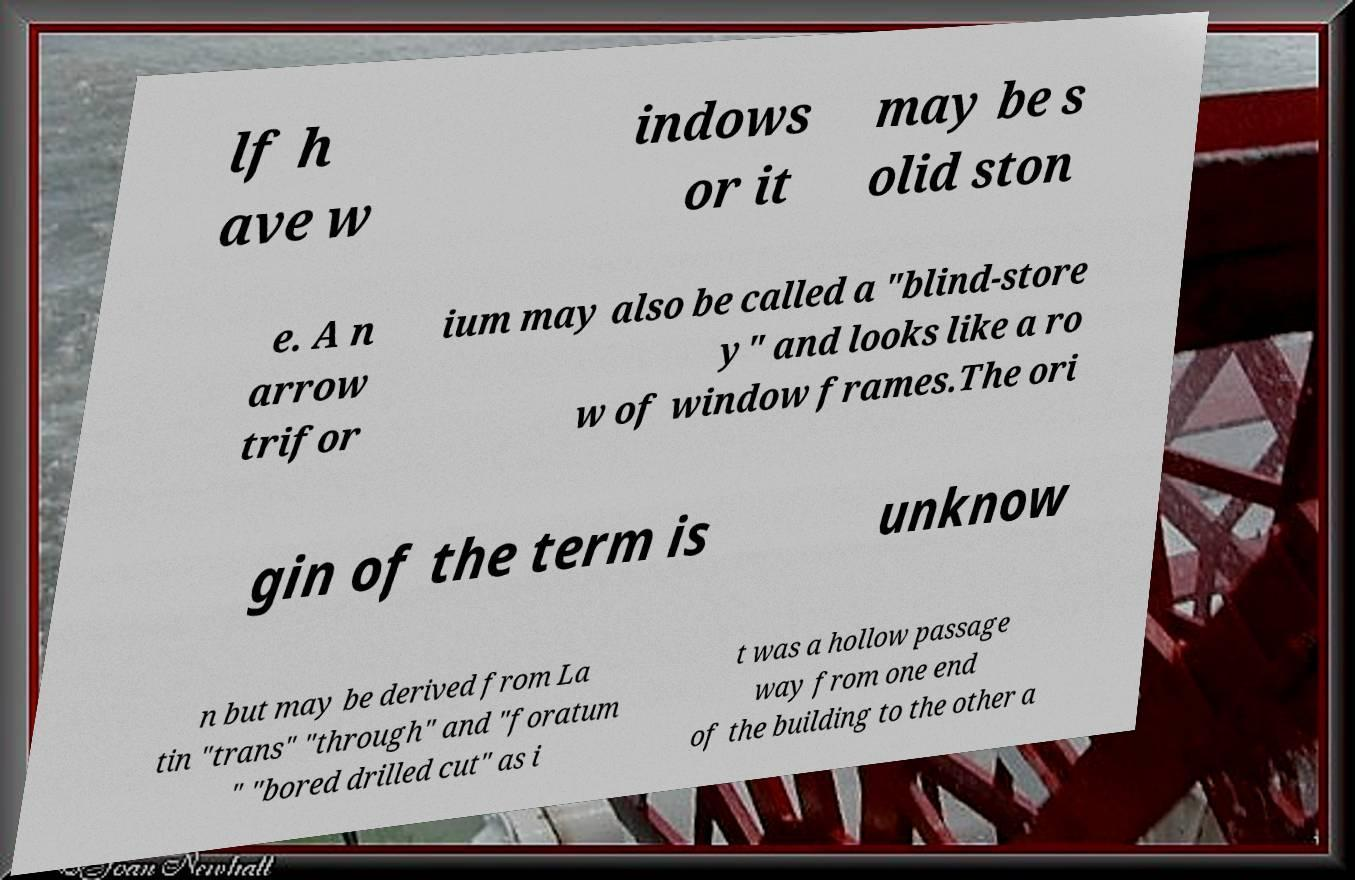I need the written content from this picture converted into text. Can you do that? lf h ave w indows or it may be s olid ston e. A n arrow trifor ium may also be called a "blind-store y" and looks like a ro w of window frames.The ori gin of the term is unknow n but may be derived from La tin "trans" "through" and "foratum " "bored drilled cut" as i t was a hollow passage way from one end of the building to the other a 